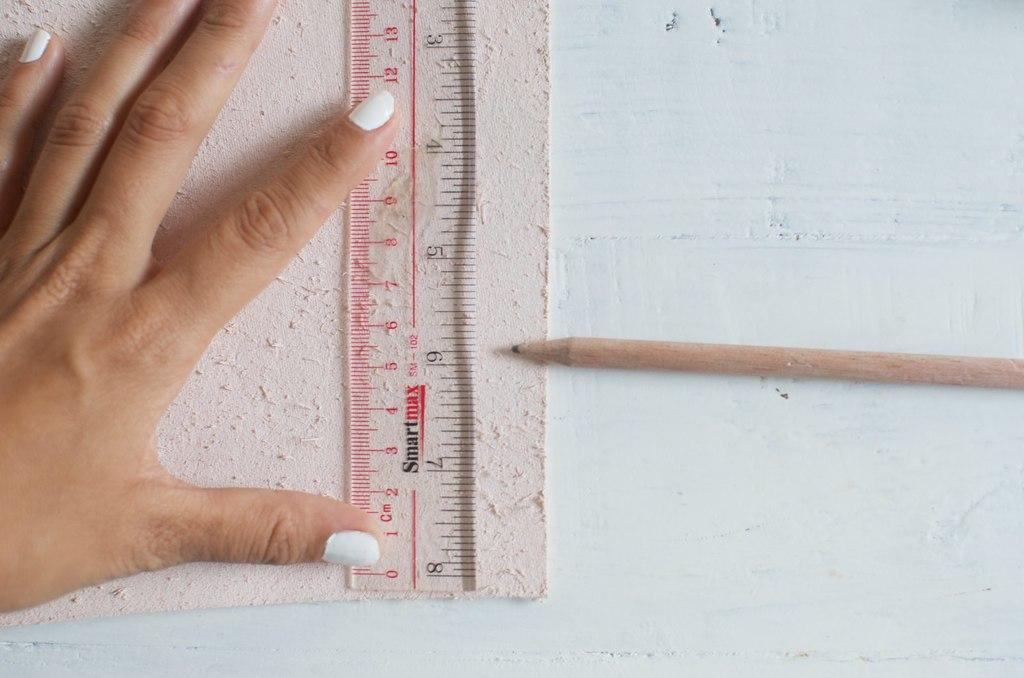Provide a one-sentence caption for the provided image. A ruler, made by Smart max, displays many different numbers. 